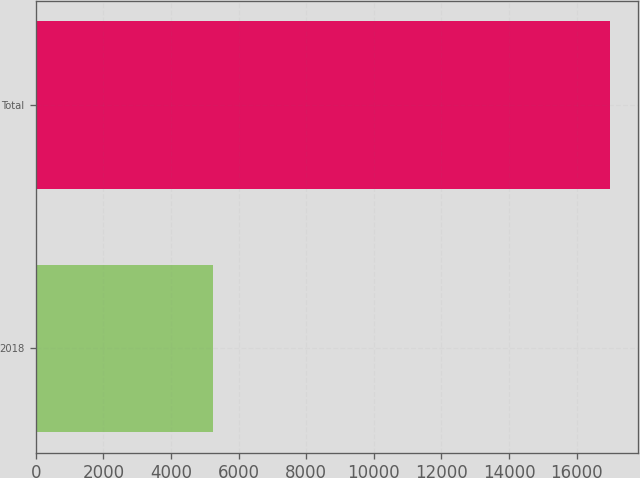Convert chart to OTSL. <chart><loc_0><loc_0><loc_500><loc_500><bar_chart><fcel>2018<fcel>Total<nl><fcel>5236<fcel>16974<nl></chart> 